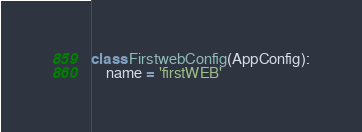Convert code to text. <code><loc_0><loc_0><loc_500><loc_500><_Python_>

class FirstwebConfig(AppConfig):
    name = 'firstWEB'
</code> 